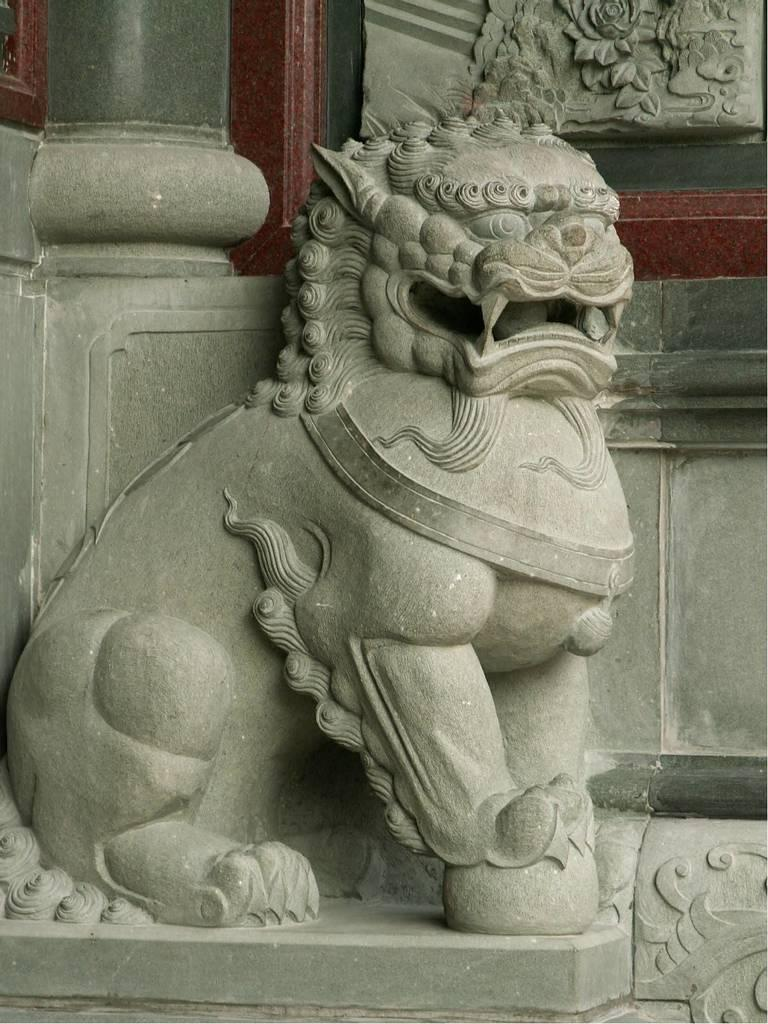What is the main subject of the image? There is a sculpture of an animal in the image. Can you describe the background of the image? There is a wall in the background of the image. What type of flowers are growing on the animal sculpture in the image? There are no flowers present on the animal sculpture in the image. 